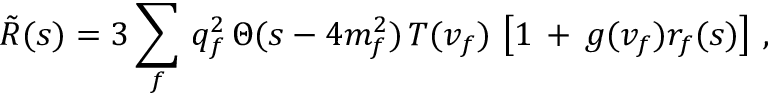Convert formula to latex. <formula><loc_0><loc_0><loc_500><loc_500>\tilde { R } ( s ) = 3 \sum _ { f } \, q _ { f } ^ { 2 } \, \Theta ( s - 4 m _ { f } ^ { 2 } ) \, T ( v _ { f } ) \, \left [ 1 \, + \, g ( v _ { f } ) r _ { f } ( s ) \right ] \, ,</formula> 